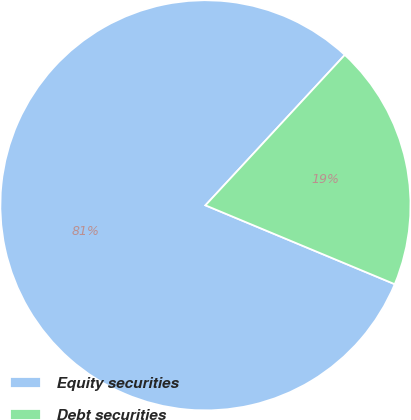Convert chart. <chart><loc_0><loc_0><loc_500><loc_500><pie_chart><fcel>Equity securities<fcel>Debt securities<nl><fcel>80.61%<fcel>19.39%<nl></chart> 